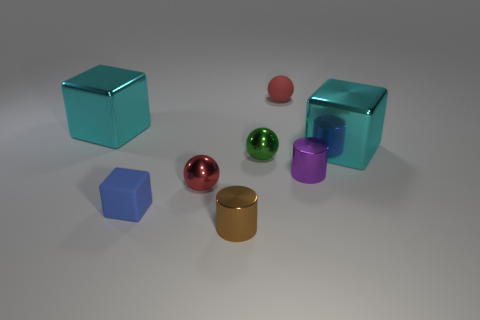There is a brown metallic cylinder; what number of tiny brown metallic cylinders are behind it?
Provide a succinct answer. 0. What is the size of the rubber ball?
Your response must be concise. Small. There is a rubber thing that is the same size as the matte ball; what is its color?
Your answer should be compact. Blue. Are there any rubber cubes that have the same color as the rubber sphere?
Make the answer very short. No. What is the blue thing made of?
Offer a very short reply. Rubber. How many tiny shiny things are there?
Ensure brevity in your answer.  4. Does the small matte object that is behind the small green sphere have the same color as the shiny cylinder behind the small brown cylinder?
Provide a succinct answer. No. What size is the shiny thing that is the same color as the rubber ball?
Provide a succinct answer. Small. How many other things are the same size as the matte ball?
Offer a very short reply. 5. What color is the ball that is in front of the purple object?
Provide a short and direct response. Red. 